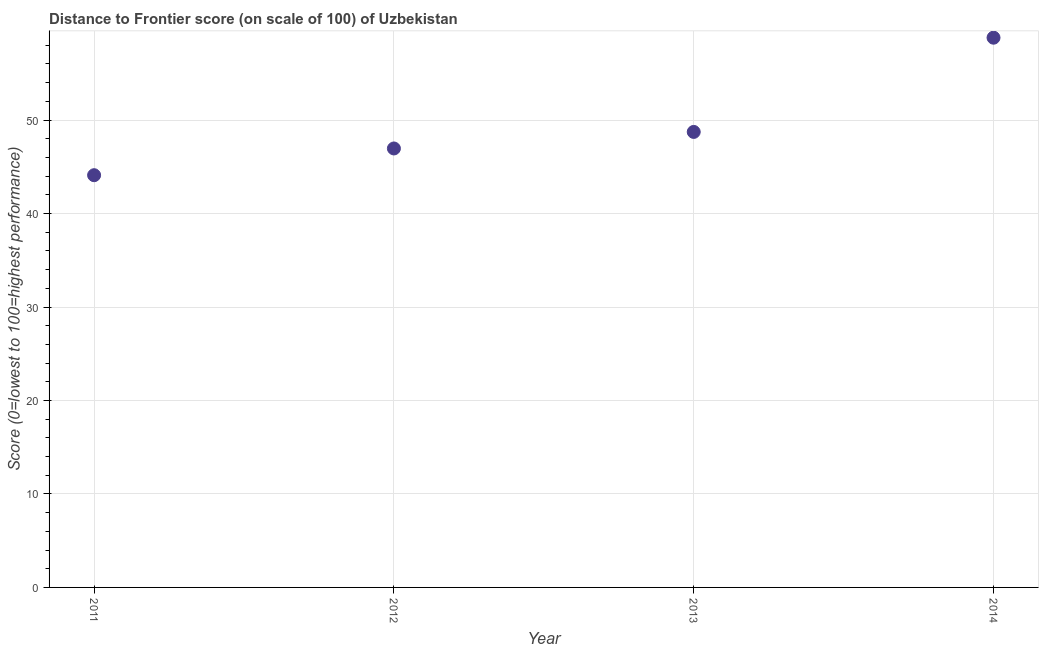What is the distance to frontier score in 2013?
Ensure brevity in your answer.  48.73. Across all years, what is the maximum distance to frontier score?
Ensure brevity in your answer.  58.81. Across all years, what is the minimum distance to frontier score?
Ensure brevity in your answer.  44.1. In which year was the distance to frontier score maximum?
Offer a terse response. 2014. What is the sum of the distance to frontier score?
Give a very brief answer. 198.6. What is the difference between the distance to frontier score in 2012 and 2014?
Offer a very short reply. -11.85. What is the average distance to frontier score per year?
Provide a short and direct response. 49.65. What is the median distance to frontier score?
Offer a very short reply. 47.84. Do a majority of the years between 2012 and 2013 (inclusive) have distance to frontier score greater than 6 ?
Ensure brevity in your answer.  Yes. What is the ratio of the distance to frontier score in 2012 to that in 2013?
Your response must be concise. 0.96. Is the distance to frontier score in 2012 less than that in 2014?
Offer a very short reply. Yes. What is the difference between the highest and the second highest distance to frontier score?
Offer a very short reply. 10.08. Is the sum of the distance to frontier score in 2011 and 2012 greater than the maximum distance to frontier score across all years?
Make the answer very short. Yes. What is the difference between the highest and the lowest distance to frontier score?
Give a very brief answer. 14.71. Does the graph contain grids?
Ensure brevity in your answer.  Yes. What is the title of the graph?
Provide a short and direct response. Distance to Frontier score (on scale of 100) of Uzbekistan. What is the label or title of the Y-axis?
Provide a short and direct response. Score (0=lowest to 100=highest performance). What is the Score (0=lowest to 100=highest performance) in 2011?
Your answer should be compact. 44.1. What is the Score (0=lowest to 100=highest performance) in 2012?
Ensure brevity in your answer.  46.96. What is the Score (0=lowest to 100=highest performance) in 2013?
Provide a succinct answer. 48.73. What is the Score (0=lowest to 100=highest performance) in 2014?
Your response must be concise. 58.81. What is the difference between the Score (0=lowest to 100=highest performance) in 2011 and 2012?
Offer a very short reply. -2.86. What is the difference between the Score (0=lowest to 100=highest performance) in 2011 and 2013?
Offer a terse response. -4.63. What is the difference between the Score (0=lowest to 100=highest performance) in 2011 and 2014?
Provide a short and direct response. -14.71. What is the difference between the Score (0=lowest to 100=highest performance) in 2012 and 2013?
Offer a very short reply. -1.77. What is the difference between the Score (0=lowest to 100=highest performance) in 2012 and 2014?
Provide a short and direct response. -11.85. What is the difference between the Score (0=lowest to 100=highest performance) in 2013 and 2014?
Offer a very short reply. -10.08. What is the ratio of the Score (0=lowest to 100=highest performance) in 2011 to that in 2012?
Give a very brief answer. 0.94. What is the ratio of the Score (0=lowest to 100=highest performance) in 2011 to that in 2013?
Offer a very short reply. 0.91. What is the ratio of the Score (0=lowest to 100=highest performance) in 2012 to that in 2013?
Your answer should be compact. 0.96. What is the ratio of the Score (0=lowest to 100=highest performance) in 2012 to that in 2014?
Ensure brevity in your answer.  0.8. What is the ratio of the Score (0=lowest to 100=highest performance) in 2013 to that in 2014?
Your response must be concise. 0.83. 